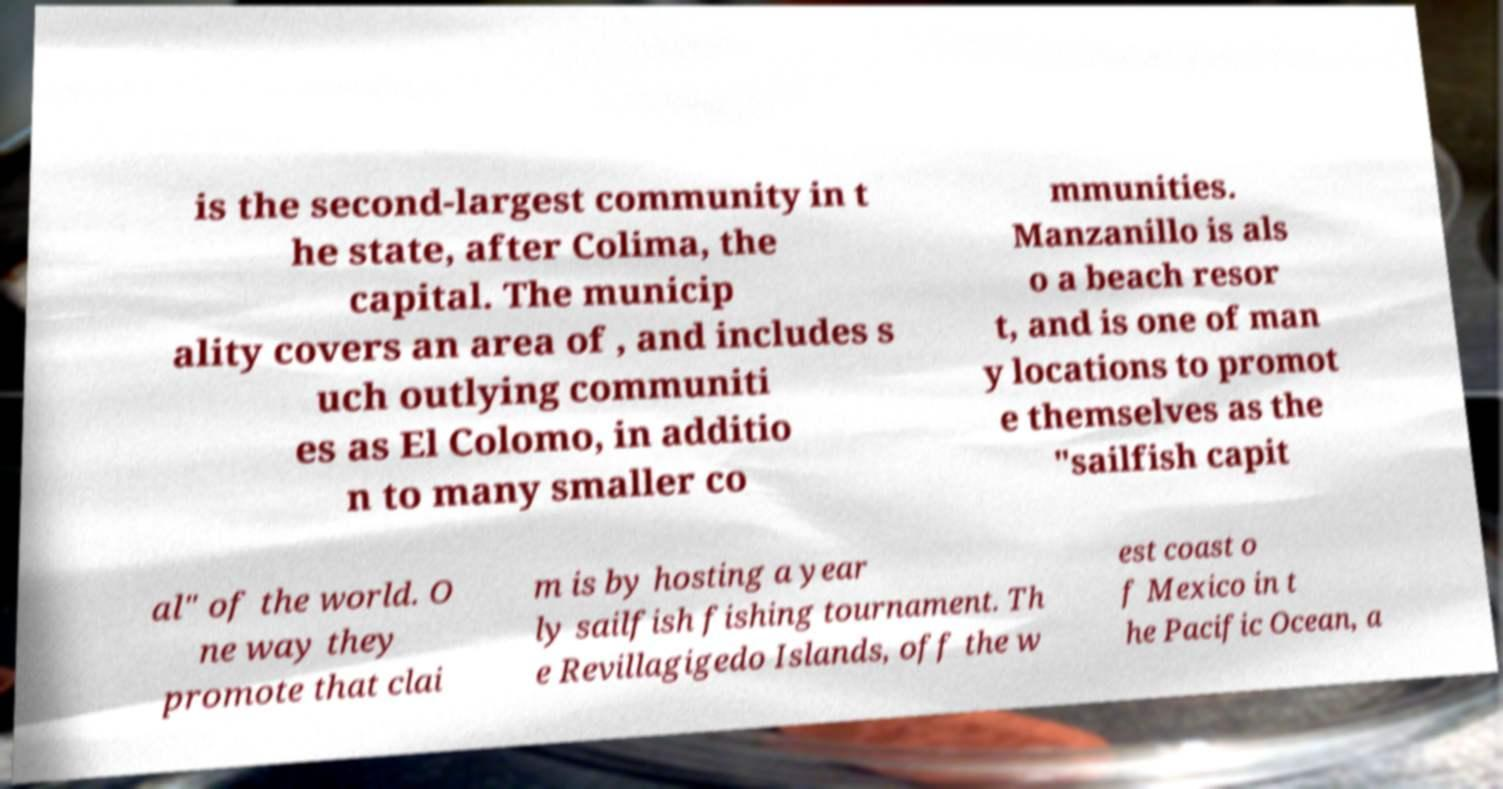Could you extract and type out the text from this image? is the second-largest community in t he state, after Colima, the capital. The municip ality covers an area of , and includes s uch outlying communiti es as El Colomo, in additio n to many smaller co mmunities. Manzanillo is als o a beach resor t, and is one of man y locations to promot e themselves as the "sailfish capit al" of the world. O ne way they promote that clai m is by hosting a year ly sailfish fishing tournament. Th e Revillagigedo Islands, off the w est coast o f Mexico in t he Pacific Ocean, a 